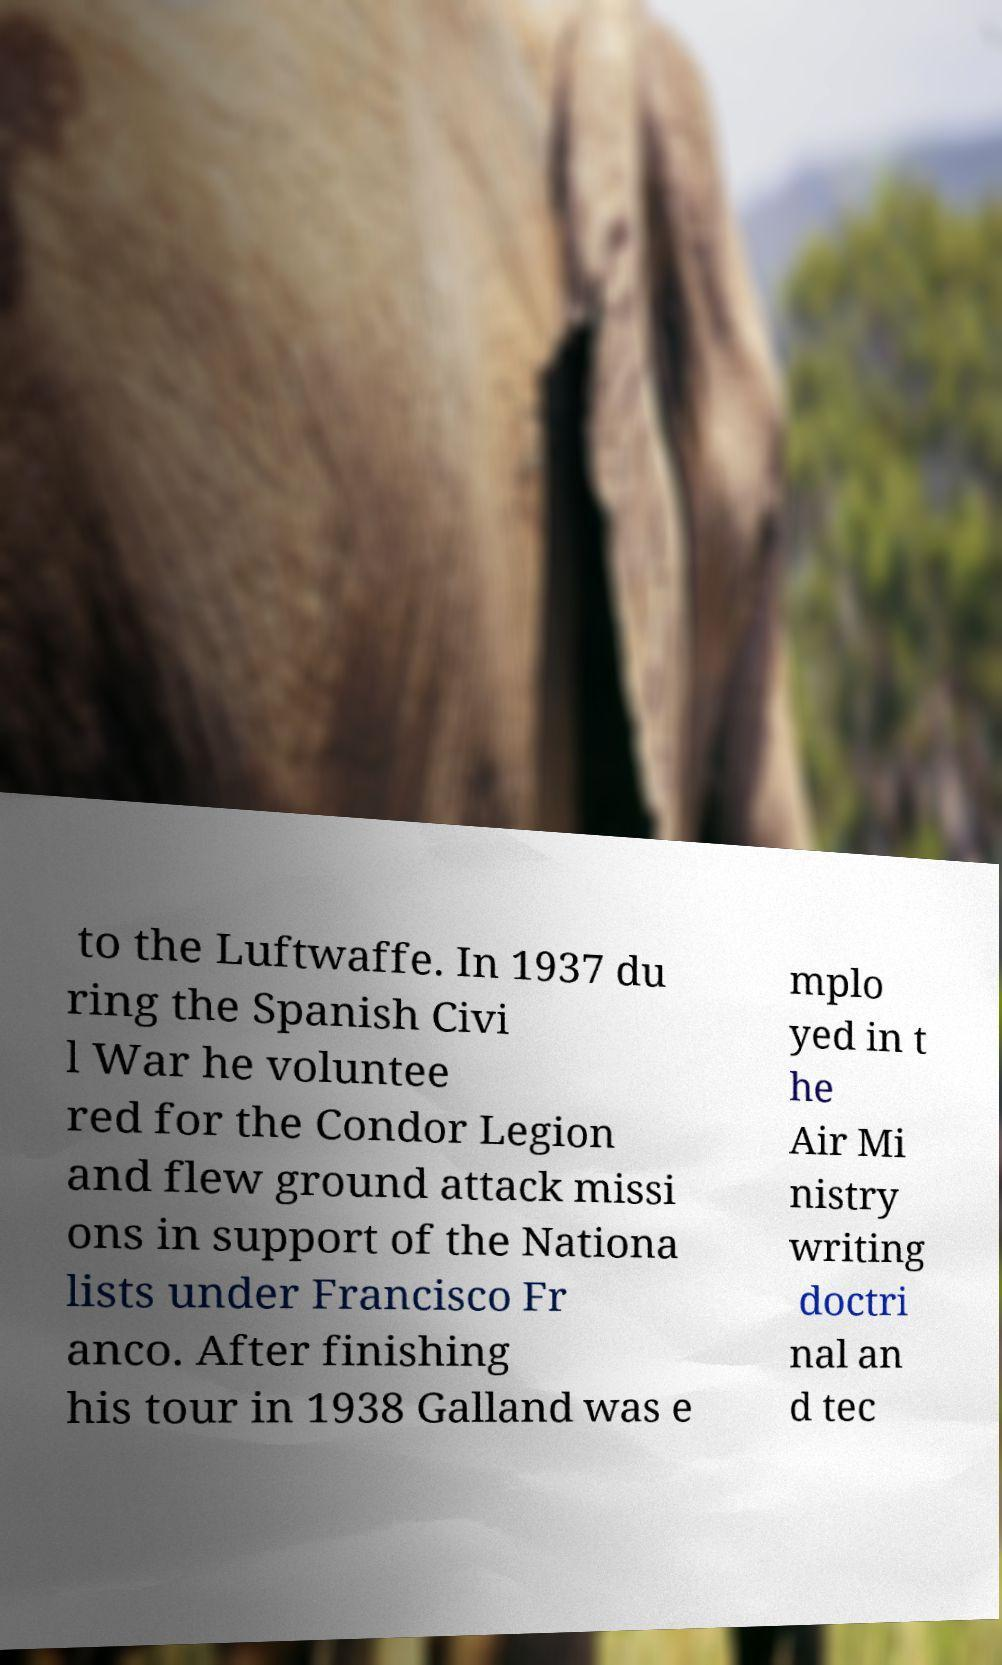What messages or text are displayed in this image? I need them in a readable, typed format. to the Luftwaffe. In 1937 du ring the Spanish Civi l War he voluntee red for the Condor Legion and flew ground attack missi ons in support of the Nationa lists under Francisco Fr anco. After finishing his tour in 1938 Galland was e mplo yed in t he Air Mi nistry writing doctri nal an d tec 